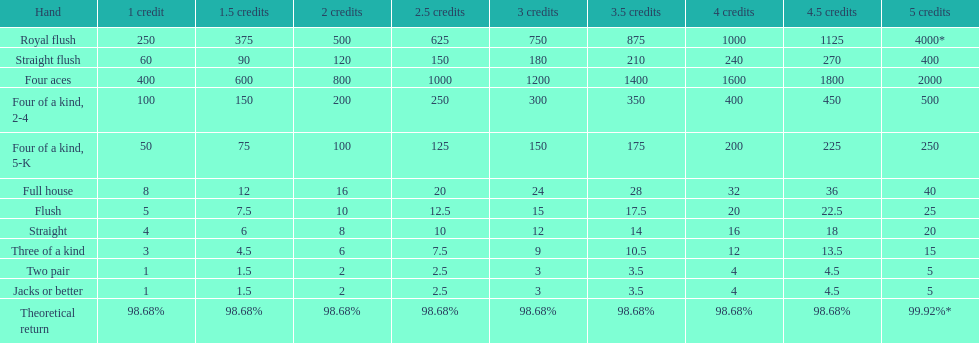Is a 2 credit full house the same as a 5 credit three of a kind? No. 